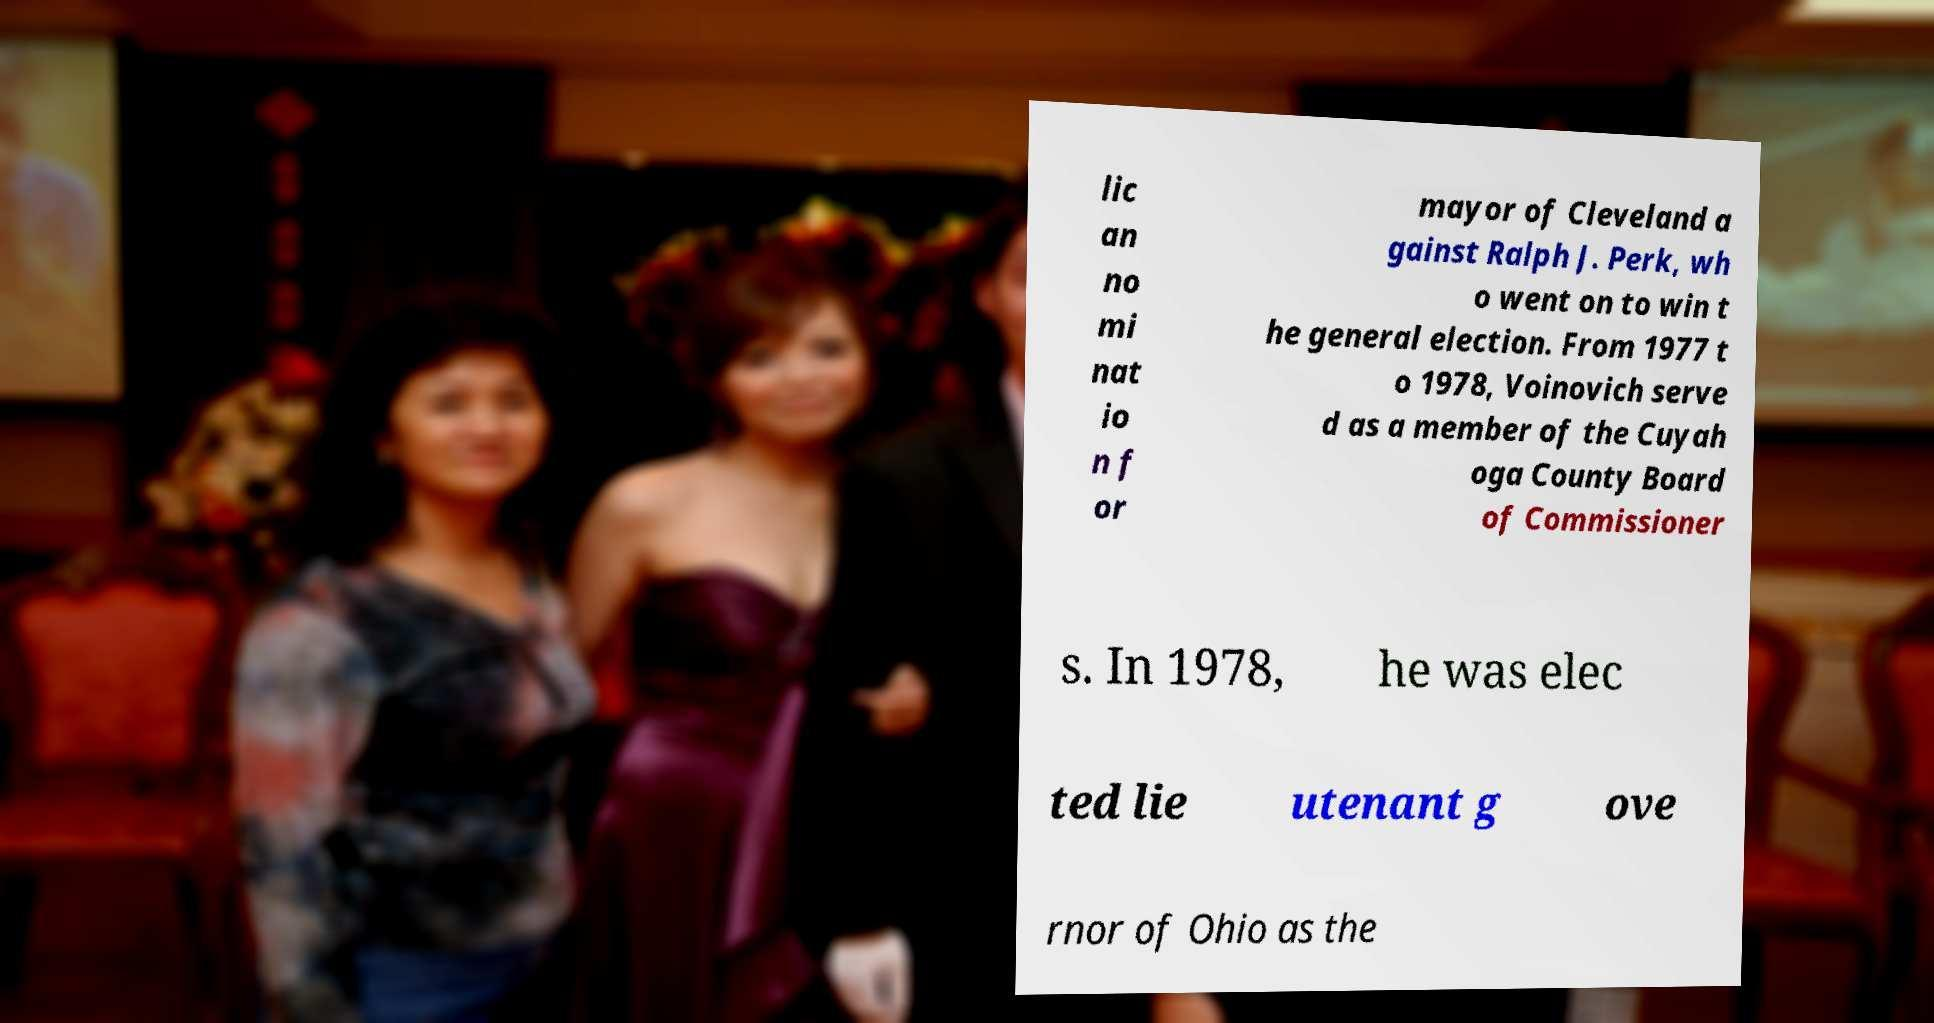There's text embedded in this image that I need extracted. Can you transcribe it verbatim? lic an no mi nat io n f or mayor of Cleveland a gainst Ralph J. Perk, wh o went on to win t he general election. From 1977 t o 1978, Voinovich serve d as a member of the Cuyah oga County Board of Commissioner s. In 1978, he was elec ted lie utenant g ove rnor of Ohio as the 